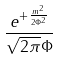<formula> <loc_0><loc_0><loc_500><loc_500>\frac { e ^ { + \frac { m ^ { 2 } } { 2 \Phi ^ { 2 } } } } { \sqrt { 2 \pi } \Phi }</formula> 